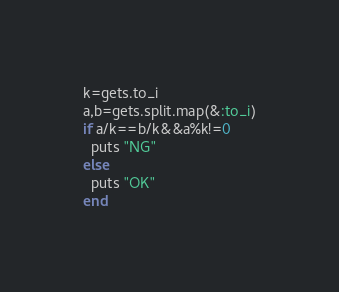<code> <loc_0><loc_0><loc_500><loc_500><_Ruby_>k=gets.to_i
a,b=gets.split.map(&:to_i)
if a/k==b/k&&a%k!=0
  puts "NG"
else
  puts "OK"
end
</code> 